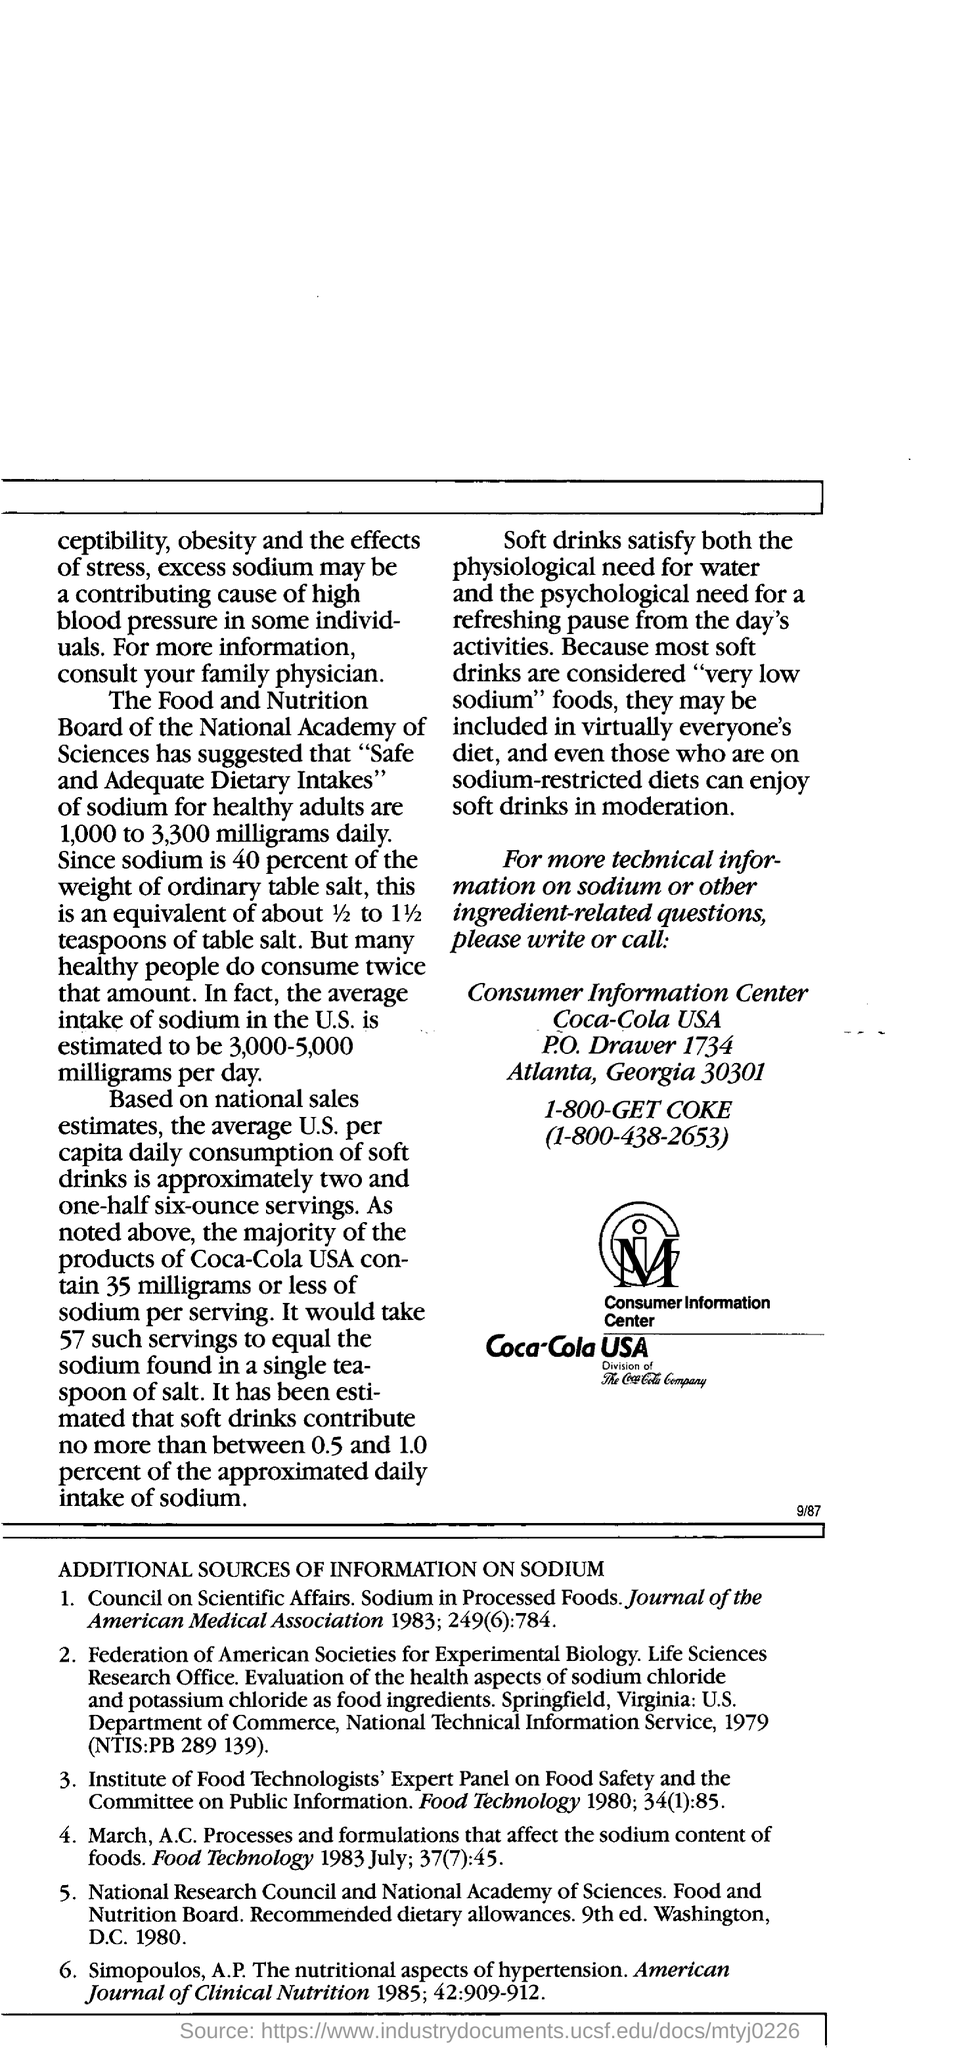Point out several critical features in this image. The average intake of sodium in the U.S. is estimated to be between 3,000 and 5,000 milligrams per day, according to recent estimates. The average daily intake of sodium in the United States is estimated to be between 3,000 and 5,000 milligrams per day. The average per capita consumption of soft drinks in the United States is approximately two and one-half six-ounce servings, based on national sales estimates. The contact number for the consumer information centre is 1-800-438-2653. 